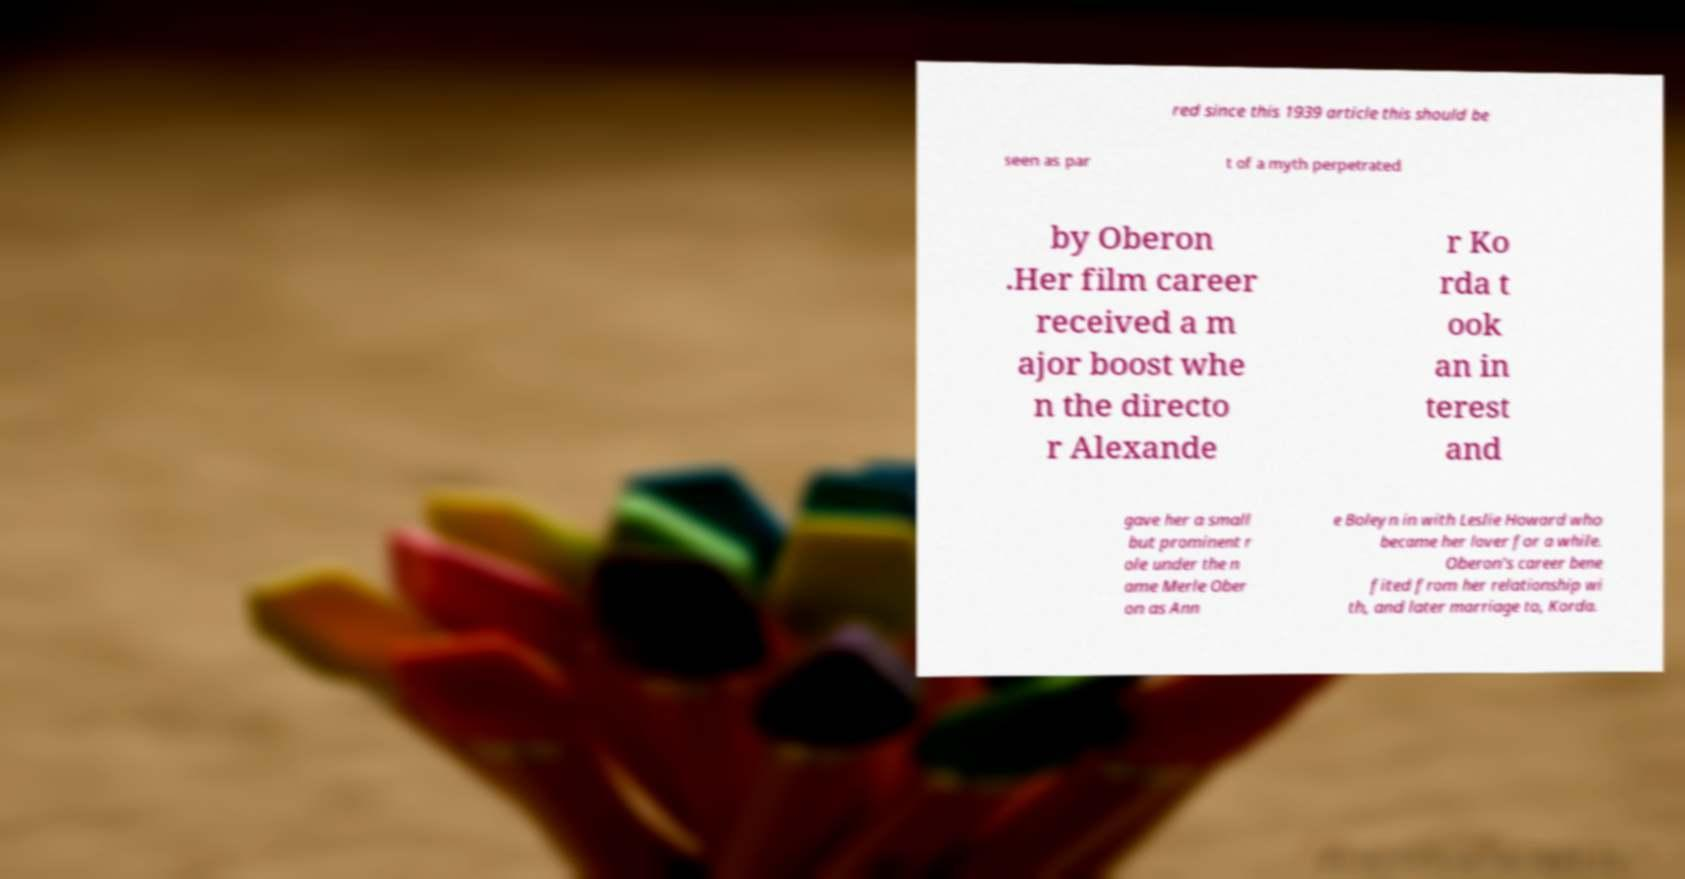For documentation purposes, I need the text within this image transcribed. Could you provide that? red since this 1939 article this should be seen as par t of a myth perpetrated by Oberon .Her film career received a m ajor boost whe n the directo r Alexande r Ko rda t ook an in terest and gave her a small but prominent r ole under the n ame Merle Ober on as Ann e Boleyn in with Leslie Howard who became her lover for a while. Oberon's career bene fited from her relationship wi th, and later marriage to, Korda. 